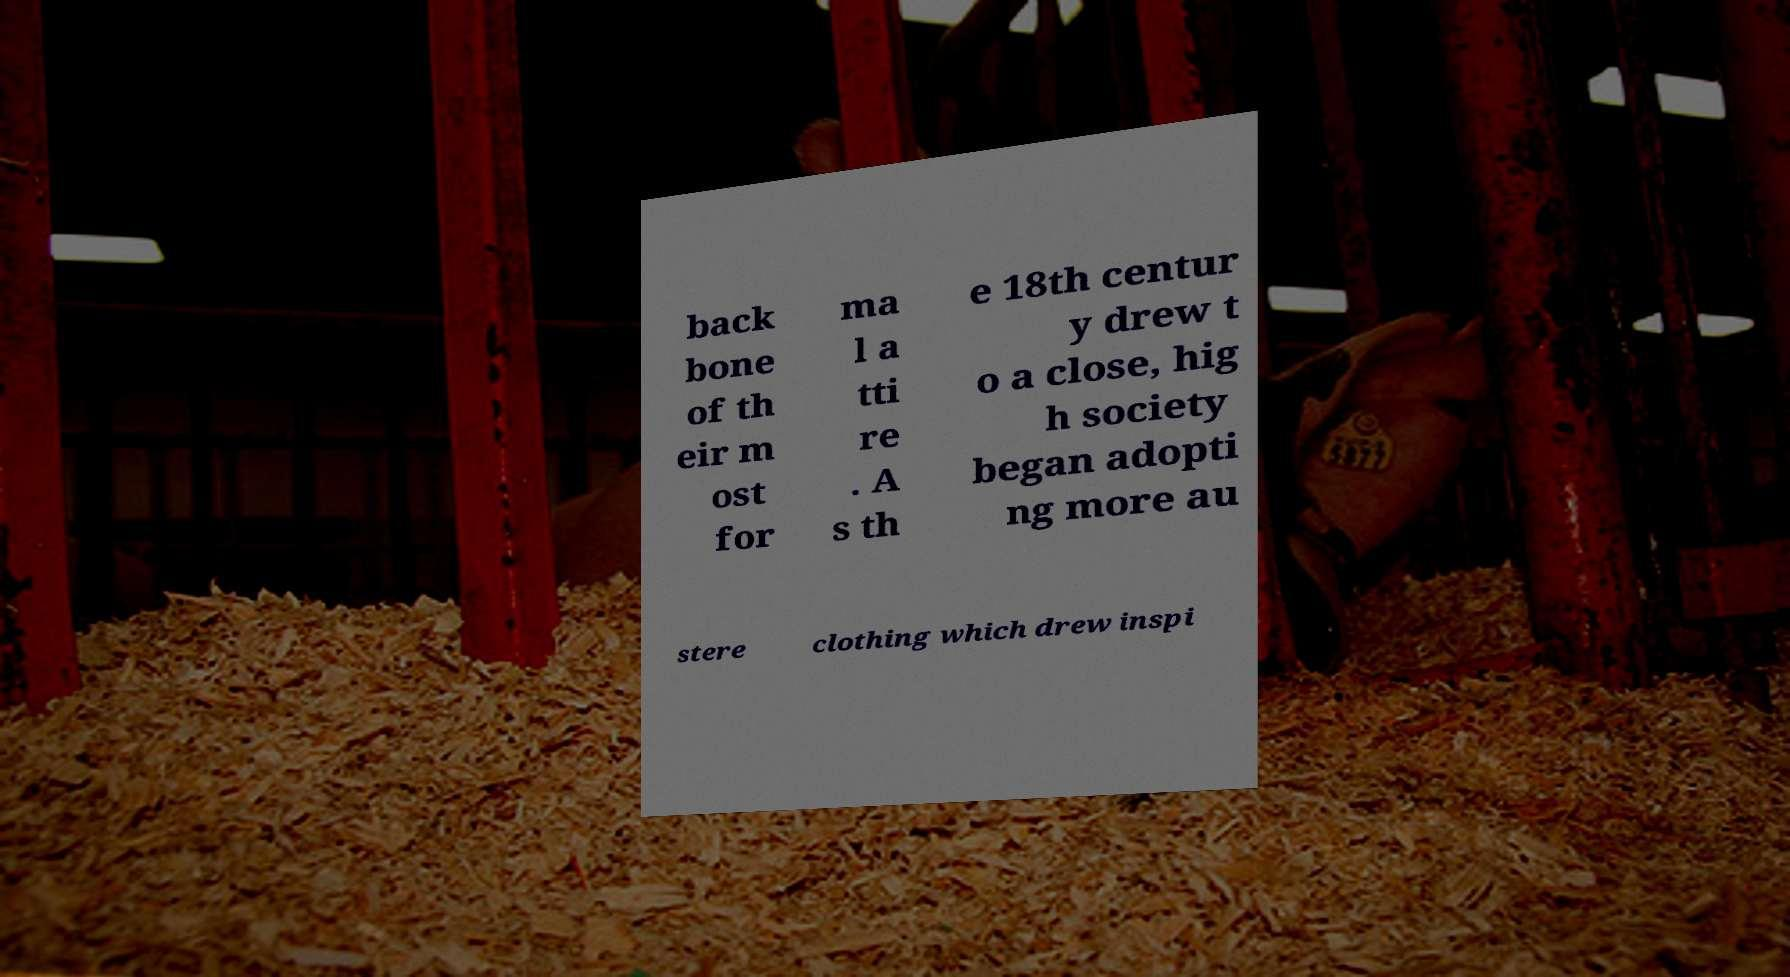Can you read and provide the text displayed in the image?This photo seems to have some interesting text. Can you extract and type it out for me? back bone of th eir m ost for ma l a tti re . A s th e 18th centur y drew t o a close, hig h society began adopti ng more au stere clothing which drew inspi 